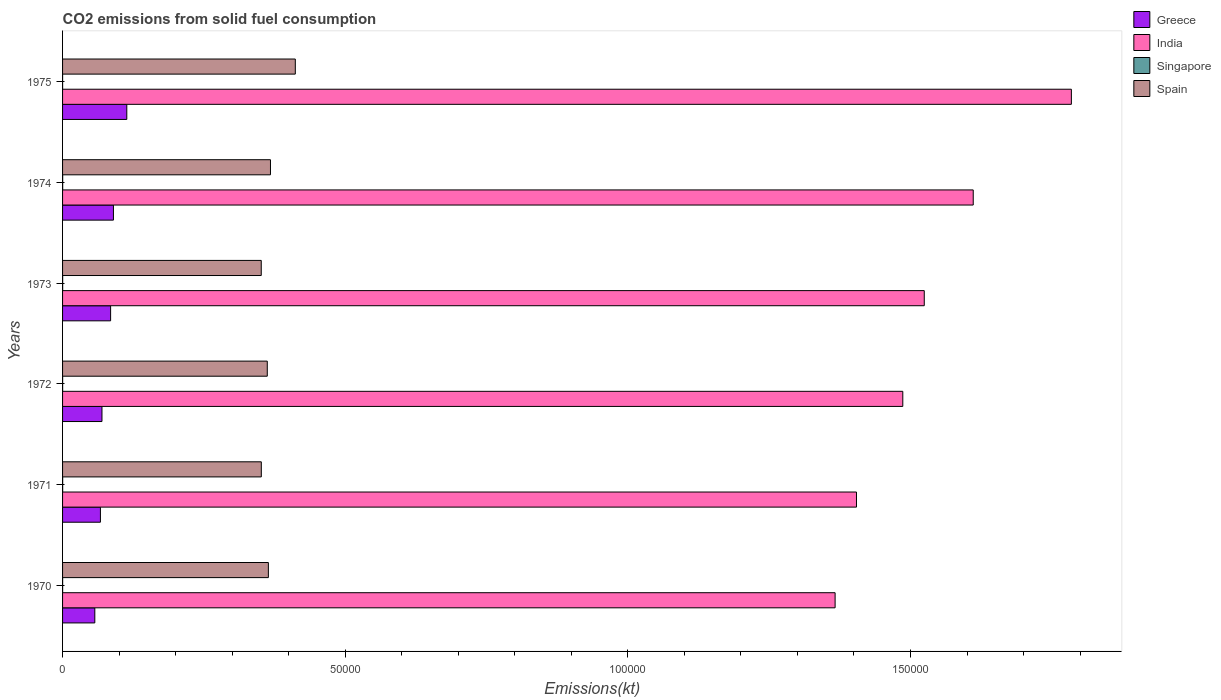How many different coloured bars are there?
Provide a succinct answer. 4. Are the number of bars on each tick of the Y-axis equal?
Provide a short and direct response. Yes. How many bars are there on the 3rd tick from the top?
Ensure brevity in your answer.  4. What is the label of the 3rd group of bars from the top?
Give a very brief answer. 1973. What is the amount of CO2 emitted in Greece in 1973?
Ensure brevity in your answer.  8500.11. Across all years, what is the maximum amount of CO2 emitted in Singapore?
Your response must be concise. 18.34. Across all years, what is the minimum amount of CO2 emitted in India?
Offer a very short reply. 1.37e+05. In which year was the amount of CO2 emitted in Spain maximum?
Offer a very short reply. 1975. In which year was the amount of CO2 emitted in Singapore minimum?
Provide a short and direct response. 1975. What is the total amount of CO2 emitted in Greece in the graph?
Offer a very short reply. 4.82e+04. What is the difference between the amount of CO2 emitted in Spain in 1970 and that in 1975?
Make the answer very short. -4763.43. What is the difference between the amount of CO2 emitted in India in 1973 and the amount of CO2 emitted in Greece in 1972?
Offer a very short reply. 1.45e+05. What is the average amount of CO2 emitted in Spain per year?
Ensure brevity in your answer.  3.68e+04. In the year 1973, what is the difference between the amount of CO2 emitted in Singapore and amount of CO2 emitted in India?
Your answer should be very brief. -1.52e+05. Is the difference between the amount of CO2 emitted in Singapore in 1971 and 1972 greater than the difference between the amount of CO2 emitted in India in 1971 and 1972?
Make the answer very short. Yes. What is the difference between the highest and the second highest amount of CO2 emitted in Singapore?
Keep it short and to the point. 3.67. What is the difference between the highest and the lowest amount of CO2 emitted in Singapore?
Offer a terse response. 14.67. What does the 4th bar from the top in 1973 represents?
Give a very brief answer. Greece. What does the 1st bar from the bottom in 1973 represents?
Your answer should be very brief. Greece. Is it the case that in every year, the sum of the amount of CO2 emitted in Singapore and amount of CO2 emitted in Spain is greater than the amount of CO2 emitted in India?
Offer a very short reply. No. How many years are there in the graph?
Offer a very short reply. 6. Where does the legend appear in the graph?
Ensure brevity in your answer.  Top right. What is the title of the graph?
Your answer should be compact. CO2 emissions from solid fuel consumption. Does "Turkmenistan" appear as one of the legend labels in the graph?
Make the answer very short. No. What is the label or title of the X-axis?
Offer a very short reply. Emissions(kt). What is the Emissions(kt) in Greece in 1970?
Offer a terse response. 5705.85. What is the Emissions(kt) of India in 1970?
Your answer should be compact. 1.37e+05. What is the Emissions(kt) of Singapore in 1970?
Offer a terse response. 11. What is the Emissions(kt) in Spain in 1970?
Provide a short and direct response. 3.64e+04. What is the Emissions(kt) of Greece in 1971?
Provide a short and direct response. 6695.94. What is the Emissions(kt) in India in 1971?
Your answer should be compact. 1.40e+05. What is the Emissions(kt) of Singapore in 1971?
Make the answer very short. 14.67. What is the Emissions(kt) of Spain in 1971?
Ensure brevity in your answer.  3.52e+04. What is the Emissions(kt) in Greece in 1972?
Your answer should be very brief. 6970.97. What is the Emissions(kt) of India in 1972?
Keep it short and to the point. 1.49e+05. What is the Emissions(kt) of Singapore in 1972?
Give a very brief answer. 11. What is the Emissions(kt) of Spain in 1972?
Offer a terse response. 3.62e+04. What is the Emissions(kt) in Greece in 1973?
Give a very brief answer. 8500.11. What is the Emissions(kt) in India in 1973?
Offer a terse response. 1.52e+05. What is the Emissions(kt) in Singapore in 1973?
Your answer should be very brief. 14.67. What is the Emissions(kt) in Spain in 1973?
Your answer should be compact. 3.51e+04. What is the Emissions(kt) of Greece in 1974?
Make the answer very short. 8998.82. What is the Emissions(kt) of India in 1974?
Your answer should be very brief. 1.61e+05. What is the Emissions(kt) in Singapore in 1974?
Provide a succinct answer. 18.34. What is the Emissions(kt) in Spain in 1974?
Your answer should be compact. 3.68e+04. What is the Emissions(kt) in Greece in 1975?
Your response must be concise. 1.14e+04. What is the Emissions(kt) in India in 1975?
Offer a very short reply. 1.78e+05. What is the Emissions(kt) of Singapore in 1975?
Your answer should be very brief. 3.67. What is the Emissions(kt) in Spain in 1975?
Ensure brevity in your answer.  4.12e+04. Across all years, what is the maximum Emissions(kt) of Greece?
Keep it short and to the point. 1.14e+04. Across all years, what is the maximum Emissions(kt) in India?
Make the answer very short. 1.78e+05. Across all years, what is the maximum Emissions(kt) of Singapore?
Make the answer very short. 18.34. Across all years, what is the maximum Emissions(kt) in Spain?
Offer a very short reply. 4.12e+04. Across all years, what is the minimum Emissions(kt) of Greece?
Keep it short and to the point. 5705.85. Across all years, what is the minimum Emissions(kt) of India?
Your response must be concise. 1.37e+05. Across all years, what is the minimum Emissions(kt) in Singapore?
Your answer should be compact. 3.67. Across all years, what is the minimum Emissions(kt) of Spain?
Offer a terse response. 3.51e+04. What is the total Emissions(kt) of Greece in the graph?
Keep it short and to the point. 4.82e+04. What is the total Emissions(kt) in India in the graph?
Your answer should be compact. 9.18e+05. What is the total Emissions(kt) of Singapore in the graph?
Your answer should be compact. 73.34. What is the total Emissions(kt) in Spain in the graph?
Keep it short and to the point. 2.21e+05. What is the difference between the Emissions(kt) of Greece in 1970 and that in 1971?
Keep it short and to the point. -990.09. What is the difference between the Emissions(kt) of India in 1970 and that in 1971?
Offer a very short reply. -3780.68. What is the difference between the Emissions(kt) of Singapore in 1970 and that in 1971?
Offer a very short reply. -3.67. What is the difference between the Emissions(kt) of Spain in 1970 and that in 1971?
Your answer should be compact. 1250.45. What is the difference between the Emissions(kt) of Greece in 1970 and that in 1972?
Provide a short and direct response. -1265.12. What is the difference between the Emissions(kt) of India in 1970 and that in 1972?
Your answer should be compact. -1.20e+04. What is the difference between the Emissions(kt) of Singapore in 1970 and that in 1972?
Offer a very short reply. 0. What is the difference between the Emissions(kt) in Spain in 1970 and that in 1972?
Offer a terse response. 194.35. What is the difference between the Emissions(kt) in Greece in 1970 and that in 1973?
Ensure brevity in your answer.  -2794.25. What is the difference between the Emissions(kt) in India in 1970 and that in 1973?
Your answer should be compact. -1.58e+04. What is the difference between the Emissions(kt) in Singapore in 1970 and that in 1973?
Give a very brief answer. -3.67. What is the difference between the Emissions(kt) of Spain in 1970 and that in 1973?
Offer a very short reply. 1261.45. What is the difference between the Emissions(kt) in Greece in 1970 and that in 1974?
Provide a succinct answer. -3292.97. What is the difference between the Emissions(kt) in India in 1970 and that in 1974?
Offer a very short reply. -2.44e+04. What is the difference between the Emissions(kt) of Singapore in 1970 and that in 1974?
Offer a very short reply. -7.33. What is the difference between the Emissions(kt) of Spain in 1970 and that in 1974?
Your response must be concise. -370.37. What is the difference between the Emissions(kt) in Greece in 1970 and that in 1975?
Provide a succinct answer. -5658.18. What is the difference between the Emissions(kt) of India in 1970 and that in 1975?
Your response must be concise. -4.18e+04. What is the difference between the Emissions(kt) of Singapore in 1970 and that in 1975?
Ensure brevity in your answer.  7.33. What is the difference between the Emissions(kt) of Spain in 1970 and that in 1975?
Make the answer very short. -4763.43. What is the difference between the Emissions(kt) of Greece in 1971 and that in 1972?
Provide a succinct answer. -275.02. What is the difference between the Emissions(kt) in India in 1971 and that in 1972?
Offer a terse response. -8192.08. What is the difference between the Emissions(kt) of Singapore in 1971 and that in 1972?
Provide a succinct answer. 3.67. What is the difference between the Emissions(kt) in Spain in 1971 and that in 1972?
Offer a very short reply. -1056.1. What is the difference between the Emissions(kt) of Greece in 1971 and that in 1973?
Your response must be concise. -1804.16. What is the difference between the Emissions(kt) in India in 1971 and that in 1973?
Your answer should be very brief. -1.20e+04. What is the difference between the Emissions(kt) in Spain in 1971 and that in 1973?
Your answer should be very brief. 11. What is the difference between the Emissions(kt) of Greece in 1971 and that in 1974?
Keep it short and to the point. -2302.88. What is the difference between the Emissions(kt) in India in 1971 and that in 1974?
Offer a very short reply. -2.07e+04. What is the difference between the Emissions(kt) of Singapore in 1971 and that in 1974?
Keep it short and to the point. -3.67. What is the difference between the Emissions(kt) of Spain in 1971 and that in 1974?
Your response must be concise. -1620.81. What is the difference between the Emissions(kt) of Greece in 1971 and that in 1975?
Offer a terse response. -4668.09. What is the difference between the Emissions(kt) in India in 1971 and that in 1975?
Your answer should be compact. -3.80e+04. What is the difference between the Emissions(kt) in Singapore in 1971 and that in 1975?
Offer a terse response. 11. What is the difference between the Emissions(kt) of Spain in 1971 and that in 1975?
Ensure brevity in your answer.  -6013.88. What is the difference between the Emissions(kt) in Greece in 1972 and that in 1973?
Provide a succinct answer. -1529.14. What is the difference between the Emissions(kt) in India in 1972 and that in 1973?
Your response must be concise. -3799.01. What is the difference between the Emissions(kt) of Singapore in 1972 and that in 1973?
Offer a terse response. -3.67. What is the difference between the Emissions(kt) of Spain in 1972 and that in 1973?
Give a very brief answer. 1067.1. What is the difference between the Emissions(kt) in Greece in 1972 and that in 1974?
Offer a very short reply. -2027.85. What is the difference between the Emissions(kt) in India in 1972 and that in 1974?
Provide a short and direct response. -1.25e+04. What is the difference between the Emissions(kt) of Singapore in 1972 and that in 1974?
Your answer should be very brief. -7.33. What is the difference between the Emissions(kt) in Spain in 1972 and that in 1974?
Provide a short and direct response. -564.72. What is the difference between the Emissions(kt) in Greece in 1972 and that in 1975?
Offer a terse response. -4393.07. What is the difference between the Emissions(kt) in India in 1972 and that in 1975?
Offer a very short reply. -2.98e+04. What is the difference between the Emissions(kt) of Singapore in 1972 and that in 1975?
Offer a very short reply. 7.33. What is the difference between the Emissions(kt) in Spain in 1972 and that in 1975?
Ensure brevity in your answer.  -4957.78. What is the difference between the Emissions(kt) in Greece in 1973 and that in 1974?
Ensure brevity in your answer.  -498.71. What is the difference between the Emissions(kt) in India in 1973 and that in 1974?
Provide a succinct answer. -8661.45. What is the difference between the Emissions(kt) in Singapore in 1973 and that in 1974?
Provide a succinct answer. -3.67. What is the difference between the Emissions(kt) in Spain in 1973 and that in 1974?
Make the answer very short. -1631.82. What is the difference between the Emissions(kt) of Greece in 1973 and that in 1975?
Ensure brevity in your answer.  -2863.93. What is the difference between the Emissions(kt) of India in 1973 and that in 1975?
Ensure brevity in your answer.  -2.60e+04. What is the difference between the Emissions(kt) in Singapore in 1973 and that in 1975?
Offer a terse response. 11. What is the difference between the Emissions(kt) in Spain in 1973 and that in 1975?
Offer a terse response. -6024.88. What is the difference between the Emissions(kt) of Greece in 1974 and that in 1975?
Provide a succinct answer. -2365.22. What is the difference between the Emissions(kt) of India in 1974 and that in 1975?
Your answer should be very brief. -1.74e+04. What is the difference between the Emissions(kt) of Singapore in 1974 and that in 1975?
Your answer should be compact. 14.67. What is the difference between the Emissions(kt) in Spain in 1974 and that in 1975?
Provide a short and direct response. -4393.07. What is the difference between the Emissions(kt) of Greece in 1970 and the Emissions(kt) of India in 1971?
Provide a short and direct response. -1.35e+05. What is the difference between the Emissions(kt) of Greece in 1970 and the Emissions(kt) of Singapore in 1971?
Keep it short and to the point. 5691.18. What is the difference between the Emissions(kt) in Greece in 1970 and the Emissions(kt) in Spain in 1971?
Offer a very short reply. -2.95e+04. What is the difference between the Emissions(kt) in India in 1970 and the Emissions(kt) in Singapore in 1971?
Provide a succinct answer. 1.37e+05. What is the difference between the Emissions(kt) in India in 1970 and the Emissions(kt) in Spain in 1971?
Your answer should be compact. 1.02e+05. What is the difference between the Emissions(kt) in Singapore in 1970 and the Emissions(kt) in Spain in 1971?
Provide a succinct answer. -3.51e+04. What is the difference between the Emissions(kt) in Greece in 1970 and the Emissions(kt) in India in 1972?
Provide a succinct answer. -1.43e+05. What is the difference between the Emissions(kt) of Greece in 1970 and the Emissions(kt) of Singapore in 1972?
Ensure brevity in your answer.  5694.85. What is the difference between the Emissions(kt) of Greece in 1970 and the Emissions(kt) of Spain in 1972?
Offer a very short reply. -3.05e+04. What is the difference between the Emissions(kt) in India in 1970 and the Emissions(kt) in Singapore in 1972?
Your answer should be compact. 1.37e+05. What is the difference between the Emissions(kt) of India in 1970 and the Emissions(kt) of Spain in 1972?
Ensure brevity in your answer.  1.00e+05. What is the difference between the Emissions(kt) in Singapore in 1970 and the Emissions(kt) in Spain in 1972?
Your response must be concise. -3.62e+04. What is the difference between the Emissions(kt) of Greece in 1970 and the Emissions(kt) of India in 1973?
Ensure brevity in your answer.  -1.47e+05. What is the difference between the Emissions(kt) in Greece in 1970 and the Emissions(kt) in Singapore in 1973?
Offer a very short reply. 5691.18. What is the difference between the Emissions(kt) of Greece in 1970 and the Emissions(kt) of Spain in 1973?
Offer a very short reply. -2.94e+04. What is the difference between the Emissions(kt) in India in 1970 and the Emissions(kt) in Singapore in 1973?
Keep it short and to the point. 1.37e+05. What is the difference between the Emissions(kt) of India in 1970 and the Emissions(kt) of Spain in 1973?
Give a very brief answer. 1.02e+05. What is the difference between the Emissions(kt) of Singapore in 1970 and the Emissions(kt) of Spain in 1973?
Ensure brevity in your answer.  -3.51e+04. What is the difference between the Emissions(kt) in Greece in 1970 and the Emissions(kt) in India in 1974?
Provide a succinct answer. -1.55e+05. What is the difference between the Emissions(kt) of Greece in 1970 and the Emissions(kt) of Singapore in 1974?
Your answer should be very brief. 5687.52. What is the difference between the Emissions(kt) of Greece in 1970 and the Emissions(kt) of Spain in 1974?
Your answer should be compact. -3.11e+04. What is the difference between the Emissions(kt) in India in 1970 and the Emissions(kt) in Singapore in 1974?
Keep it short and to the point. 1.37e+05. What is the difference between the Emissions(kt) of India in 1970 and the Emissions(kt) of Spain in 1974?
Your answer should be very brief. 9.99e+04. What is the difference between the Emissions(kt) in Singapore in 1970 and the Emissions(kt) in Spain in 1974?
Ensure brevity in your answer.  -3.68e+04. What is the difference between the Emissions(kt) in Greece in 1970 and the Emissions(kt) in India in 1975?
Make the answer very short. -1.73e+05. What is the difference between the Emissions(kt) in Greece in 1970 and the Emissions(kt) in Singapore in 1975?
Ensure brevity in your answer.  5702.19. What is the difference between the Emissions(kt) of Greece in 1970 and the Emissions(kt) of Spain in 1975?
Give a very brief answer. -3.55e+04. What is the difference between the Emissions(kt) of India in 1970 and the Emissions(kt) of Singapore in 1975?
Make the answer very short. 1.37e+05. What is the difference between the Emissions(kt) of India in 1970 and the Emissions(kt) of Spain in 1975?
Keep it short and to the point. 9.55e+04. What is the difference between the Emissions(kt) in Singapore in 1970 and the Emissions(kt) in Spain in 1975?
Your response must be concise. -4.12e+04. What is the difference between the Emissions(kt) of Greece in 1971 and the Emissions(kt) of India in 1972?
Ensure brevity in your answer.  -1.42e+05. What is the difference between the Emissions(kt) of Greece in 1971 and the Emissions(kt) of Singapore in 1972?
Keep it short and to the point. 6684.94. What is the difference between the Emissions(kt) in Greece in 1971 and the Emissions(kt) in Spain in 1972?
Provide a succinct answer. -2.95e+04. What is the difference between the Emissions(kt) in India in 1971 and the Emissions(kt) in Singapore in 1972?
Keep it short and to the point. 1.40e+05. What is the difference between the Emissions(kt) of India in 1971 and the Emissions(kt) of Spain in 1972?
Give a very brief answer. 1.04e+05. What is the difference between the Emissions(kt) in Singapore in 1971 and the Emissions(kt) in Spain in 1972?
Keep it short and to the point. -3.62e+04. What is the difference between the Emissions(kt) of Greece in 1971 and the Emissions(kt) of India in 1973?
Ensure brevity in your answer.  -1.46e+05. What is the difference between the Emissions(kt) in Greece in 1971 and the Emissions(kt) in Singapore in 1973?
Offer a very short reply. 6681.27. What is the difference between the Emissions(kt) of Greece in 1971 and the Emissions(kt) of Spain in 1973?
Keep it short and to the point. -2.85e+04. What is the difference between the Emissions(kt) of India in 1971 and the Emissions(kt) of Singapore in 1973?
Ensure brevity in your answer.  1.40e+05. What is the difference between the Emissions(kt) in India in 1971 and the Emissions(kt) in Spain in 1973?
Keep it short and to the point. 1.05e+05. What is the difference between the Emissions(kt) of Singapore in 1971 and the Emissions(kt) of Spain in 1973?
Your answer should be compact. -3.51e+04. What is the difference between the Emissions(kt) of Greece in 1971 and the Emissions(kt) of India in 1974?
Offer a very short reply. -1.54e+05. What is the difference between the Emissions(kt) in Greece in 1971 and the Emissions(kt) in Singapore in 1974?
Ensure brevity in your answer.  6677.61. What is the difference between the Emissions(kt) in Greece in 1971 and the Emissions(kt) in Spain in 1974?
Keep it short and to the point. -3.01e+04. What is the difference between the Emissions(kt) of India in 1971 and the Emissions(kt) of Singapore in 1974?
Provide a succinct answer. 1.40e+05. What is the difference between the Emissions(kt) in India in 1971 and the Emissions(kt) in Spain in 1974?
Give a very brief answer. 1.04e+05. What is the difference between the Emissions(kt) of Singapore in 1971 and the Emissions(kt) of Spain in 1974?
Provide a short and direct response. -3.68e+04. What is the difference between the Emissions(kt) in Greece in 1971 and the Emissions(kt) in India in 1975?
Keep it short and to the point. -1.72e+05. What is the difference between the Emissions(kt) of Greece in 1971 and the Emissions(kt) of Singapore in 1975?
Provide a short and direct response. 6692.27. What is the difference between the Emissions(kt) of Greece in 1971 and the Emissions(kt) of Spain in 1975?
Offer a terse response. -3.45e+04. What is the difference between the Emissions(kt) in India in 1971 and the Emissions(kt) in Singapore in 1975?
Make the answer very short. 1.40e+05. What is the difference between the Emissions(kt) in India in 1971 and the Emissions(kt) in Spain in 1975?
Offer a terse response. 9.93e+04. What is the difference between the Emissions(kt) in Singapore in 1971 and the Emissions(kt) in Spain in 1975?
Offer a very short reply. -4.12e+04. What is the difference between the Emissions(kt) of Greece in 1972 and the Emissions(kt) of India in 1973?
Your answer should be very brief. -1.45e+05. What is the difference between the Emissions(kt) in Greece in 1972 and the Emissions(kt) in Singapore in 1973?
Give a very brief answer. 6956.3. What is the difference between the Emissions(kt) in Greece in 1972 and the Emissions(kt) in Spain in 1973?
Ensure brevity in your answer.  -2.82e+04. What is the difference between the Emissions(kt) in India in 1972 and the Emissions(kt) in Singapore in 1973?
Ensure brevity in your answer.  1.49e+05. What is the difference between the Emissions(kt) in India in 1972 and the Emissions(kt) in Spain in 1973?
Ensure brevity in your answer.  1.13e+05. What is the difference between the Emissions(kt) in Singapore in 1972 and the Emissions(kt) in Spain in 1973?
Your response must be concise. -3.51e+04. What is the difference between the Emissions(kt) in Greece in 1972 and the Emissions(kt) in India in 1974?
Provide a short and direct response. -1.54e+05. What is the difference between the Emissions(kt) in Greece in 1972 and the Emissions(kt) in Singapore in 1974?
Offer a terse response. 6952.63. What is the difference between the Emissions(kt) of Greece in 1972 and the Emissions(kt) of Spain in 1974?
Offer a very short reply. -2.98e+04. What is the difference between the Emissions(kt) in India in 1972 and the Emissions(kt) in Singapore in 1974?
Offer a terse response. 1.49e+05. What is the difference between the Emissions(kt) in India in 1972 and the Emissions(kt) in Spain in 1974?
Your answer should be very brief. 1.12e+05. What is the difference between the Emissions(kt) in Singapore in 1972 and the Emissions(kt) in Spain in 1974?
Ensure brevity in your answer.  -3.68e+04. What is the difference between the Emissions(kt) in Greece in 1972 and the Emissions(kt) in India in 1975?
Provide a succinct answer. -1.71e+05. What is the difference between the Emissions(kt) in Greece in 1972 and the Emissions(kt) in Singapore in 1975?
Give a very brief answer. 6967.3. What is the difference between the Emissions(kt) in Greece in 1972 and the Emissions(kt) in Spain in 1975?
Give a very brief answer. -3.42e+04. What is the difference between the Emissions(kt) in India in 1972 and the Emissions(kt) in Singapore in 1975?
Provide a succinct answer. 1.49e+05. What is the difference between the Emissions(kt) in India in 1972 and the Emissions(kt) in Spain in 1975?
Your answer should be very brief. 1.07e+05. What is the difference between the Emissions(kt) of Singapore in 1972 and the Emissions(kt) of Spain in 1975?
Make the answer very short. -4.12e+04. What is the difference between the Emissions(kt) of Greece in 1973 and the Emissions(kt) of India in 1974?
Your answer should be compact. -1.53e+05. What is the difference between the Emissions(kt) in Greece in 1973 and the Emissions(kt) in Singapore in 1974?
Offer a terse response. 8481.77. What is the difference between the Emissions(kt) in Greece in 1973 and the Emissions(kt) in Spain in 1974?
Offer a terse response. -2.83e+04. What is the difference between the Emissions(kt) of India in 1973 and the Emissions(kt) of Singapore in 1974?
Provide a short and direct response. 1.52e+05. What is the difference between the Emissions(kt) in India in 1973 and the Emissions(kt) in Spain in 1974?
Make the answer very short. 1.16e+05. What is the difference between the Emissions(kt) in Singapore in 1973 and the Emissions(kt) in Spain in 1974?
Offer a terse response. -3.68e+04. What is the difference between the Emissions(kt) of Greece in 1973 and the Emissions(kt) of India in 1975?
Make the answer very short. -1.70e+05. What is the difference between the Emissions(kt) of Greece in 1973 and the Emissions(kt) of Singapore in 1975?
Your response must be concise. 8496.44. What is the difference between the Emissions(kt) in Greece in 1973 and the Emissions(kt) in Spain in 1975?
Ensure brevity in your answer.  -3.27e+04. What is the difference between the Emissions(kt) of India in 1973 and the Emissions(kt) of Singapore in 1975?
Provide a succinct answer. 1.52e+05. What is the difference between the Emissions(kt) in India in 1973 and the Emissions(kt) in Spain in 1975?
Your answer should be very brief. 1.11e+05. What is the difference between the Emissions(kt) in Singapore in 1973 and the Emissions(kt) in Spain in 1975?
Your answer should be very brief. -4.12e+04. What is the difference between the Emissions(kt) of Greece in 1974 and the Emissions(kt) of India in 1975?
Make the answer very short. -1.69e+05. What is the difference between the Emissions(kt) in Greece in 1974 and the Emissions(kt) in Singapore in 1975?
Keep it short and to the point. 8995.15. What is the difference between the Emissions(kt) in Greece in 1974 and the Emissions(kt) in Spain in 1975?
Provide a succinct answer. -3.22e+04. What is the difference between the Emissions(kt) of India in 1974 and the Emissions(kt) of Singapore in 1975?
Keep it short and to the point. 1.61e+05. What is the difference between the Emissions(kt) in India in 1974 and the Emissions(kt) in Spain in 1975?
Your response must be concise. 1.20e+05. What is the difference between the Emissions(kt) of Singapore in 1974 and the Emissions(kt) of Spain in 1975?
Your answer should be compact. -4.12e+04. What is the average Emissions(kt) of Greece per year?
Keep it short and to the point. 8039.29. What is the average Emissions(kt) of India per year?
Provide a short and direct response. 1.53e+05. What is the average Emissions(kt) in Singapore per year?
Offer a terse response. 12.22. What is the average Emissions(kt) of Spain per year?
Offer a terse response. 3.68e+04. In the year 1970, what is the difference between the Emissions(kt) of Greece and Emissions(kt) of India?
Provide a succinct answer. -1.31e+05. In the year 1970, what is the difference between the Emissions(kt) in Greece and Emissions(kt) in Singapore?
Provide a short and direct response. 5694.85. In the year 1970, what is the difference between the Emissions(kt) in Greece and Emissions(kt) in Spain?
Your answer should be compact. -3.07e+04. In the year 1970, what is the difference between the Emissions(kt) in India and Emissions(kt) in Singapore?
Offer a very short reply. 1.37e+05. In the year 1970, what is the difference between the Emissions(kt) of India and Emissions(kt) of Spain?
Give a very brief answer. 1.00e+05. In the year 1970, what is the difference between the Emissions(kt) in Singapore and Emissions(kt) in Spain?
Provide a short and direct response. -3.64e+04. In the year 1971, what is the difference between the Emissions(kt) in Greece and Emissions(kt) in India?
Your answer should be compact. -1.34e+05. In the year 1971, what is the difference between the Emissions(kt) of Greece and Emissions(kt) of Singapore?
Your answer should be very brief. 6681.27. In the year 1971, what is the difference between the Emissions(kt) in Greece and Emissions(kt) in Spain?
Your answer should be compact. -2.85e+04. In the year 1971, what is the difference between the Emissions(kt) of India and Emissions(kt) of Singapore?
Make the answer very short. 1.40e+05. In the year 1971, what is the difference between the Emissions(kt) in India and Emissions(kt) in Spain?
Keep it short and to the point. 1.05e+05. In the year 1971, what is the difference between the Emissions(kt) of Singapore and Emissions(kt) of Spain?
Offer a very short reply. -3.51e+04. In the year 1972, what is the difference between the Emissions(kt) in Greece and Emissions(kt) in India?
Offer a terse response. -1.42e+05. In the year 1972, what is the difference between the Emissions(kt) in Greece and Emissions(kt) in Singapore?
Make the answer very short. 6959.97. In the year 1972, what is the difference between the Emissions(kt) in Greece and Emissions(kt) in Spain?
Keep it short and to the point. -2.92e+04. In the year 1972, what is the difference between the Emissions(kt) in India and Emissions(kt) in Singapore?
Give a very brief answer. 1.49e+05. In the year 1972, what is the difference between the Emissions(kt) in India and Emissions(kt) in Spain?
Offer a very short reply. 1.12e+05. In the year 1972, what is the difference between the Emissions(kt) in Singapore and Emissions(kt) in Spain?
Offer a very short reply. -3.62e+04. In the year 1973, what is the difference between the Emissions(kt) of Greece and Emissions(kt) of India?
Ensure brevity in your answer.  -1.44e+05. In the year 1973, what is the difference between the Emissions(kt) in Greece and Emissions(kt) in Singapore?
Your response must be concise. 8485.44. In the year 1973, what is the difference between the Emissions(kt) of Greece and Emissions(kt) of Spain?
Provide a short and direct response. -2.66e+04. In the year 1973, what is the difference between the Emissions(kt) of India and Emissions(kt) of Singapore?
Offer a very short reply. 1.52e+05. In the year 1973, what is the difference between the Emissions(kt) in India and Emissions(kt) in Spain?
Your answer should be very brief. 1.17e+05. In the year 1973, what is the difference between the Emissions(kt) of Singapore and Emissions(kt) of Spain?
Give a very brief answer. -3.51e+04. In the year 1974, what is the difference between the Emissions(kt) in Greece and Emissions(kt) in India?
Offer a terse response. -1.52e+05. In the year 1974, what is the difference between the Emissions(kt) in Greece and Emissions(kt) in Singapore?
Provide a succinct answer. 8980.48. In the year 1974, what is the difference between the Emissions(kt) in Greece and Emissions(kt) in Spain?
Your answer should be compact. -2.78e+04. In the year 1974, what is the difference between the Emissions(kt) in India and Emissions(kt) in Singapore?
Offer a very short reply. 1.61e+05. In the year 1974, what is the difference between the Emissions(kt) in India and Emissions(kt) in Spain?
Your response must be concise. 1.24e+05. In the year 1974, what is the difference between the Emissions(kt) of Singapore and Emissions(kt) of Spain?
Your answer should be very brief. -3.68e+04. In the year 1975, what is the difference between the Emissions(kt) of Greece and Emissions(kt) of India?
Your answer should be very brief. -1.67e+05. In the year 1975, what is the difference between the Emissions(kt) in Greece and Emissions(kt) in Singapore?
Offer a terse response. 1.14e+04. In the year 1975, what is the difference between the Emissions(kt) of Greece and Emissions(kt) of Spain?
Keep it short and to the point. -2.98e+04. In the year 1975, what is the difference between the Emissions(kt) of India and Emissions(kt) of Singapore?
Give a very brief answer. 1.78e+05. In the year 1975, what is the difference between the Emissions(kt) in India and Emissions(kt) in Spain?
Offer a terse response. 1.37e+05. In the year 1975, what is the difference between the Emissions(kt) in Singapore and Emissions(kt) in Spain?
Your answer should be compact. -4.12e+04. What is the ratio of the Emissions(kt) of Greece in 1970 to that in 1971?
Offer a terse response. 0.85. What is the ratio of the Emissions(kt) in India in 1970 to that in 1971?
Provide a succinct answer. 0.97. What is the ratio of the Emissions(kt) of Spain in 1970 to that in 1971?
Provide a short and direct response. 1.04. What is the ratio of the Emissions(kt) in Greece in 1970 to that in 1972?
Offer a terse response. 0.82. What is the ratio of the Emissions(kt) in India in 1970 to that in 1972?
Ensure brevity in your answer.  0.92. What is the ratio of the Emissions(kt) in Spain in 1970 to that in 1972?
Offer a very short reply. 1.01. What is the ratio of the Emissions(kt) of Greece in 1970 to that in 1973?
Your response must be concise. 0.67. What is the ratio of the Emissions(kt) in India in 1970 to that in 1973?
Keep it short and to the point. 0.9. What is the ratio of the Emissions(kt) in Spain in 1970 to that in 1973?
Give a very brief answer. 1.04. What is the ratio of the Emissions(kt) of Greece in 1970 to that in 1974?
Make the answer very short. 0.63. What is the ratio of the Emissions(kt) of India in 1970 to that in 1974?
Provide a short and direct response. 0.85. What is the ratio of the Emissions(kt) in Spain in 1970 to that in 1974?
Keep it short and to the point. 0.99. What is the ratio of the Emissions(kt) in Greece in 1970 to that in 1975?
Ensure brevity in your answer.  0.5. What is the ratio of the Emissions(kt) in India in 1970 to that in 1975?
Give a very brief answer. 0.77. What is the ratio of the Emissions(kt) in Singapore in 1970 to that in 1975?
Offer a terse response. 3. What is the ratio of the Emissions(kt) in Spain in 1970 to that in 1975?
Offer a terse response. 0.88. What is the ratio of the Emissions(kt) of Greece in 1971 to that in 1972?
Offer a terse response. 0.96. What is the ratio of the Emissions(kt) in India in 1971 to that in 1972?
Your answer should be very brief. 0.94. What is the ratio of the Emissions(kt) in Singapore in 1971 to that in 1972?
Offer a terse response. 1.33. What is the ratio of the Emissions(kt) in Spain in 1971 to that in 1972?
Offer a terse response. 0.97. What is the ratio of the Emissions(kt) of Greece in 1971 to that in 1973?
Give a very brief answer. 0.79. What is the ratio of the Emissions(kt) in India in 1971 to that in 1973?
Provide a succinct answer. 0.92. What is the ratio of the Emissions(kt) of Greece in 1971 to that in 1974?
Make the answer very short. 0.74. What is the ratio of the Emissions(kt) of India in 1971 to that in 1974?
Your answer should be very brief. 0.87. What is the ratio of the Emissions(kt) of Singapore in 1971 to that in 1974?
Give a very brief answer. 0.8. What is the ratio of the Emissions(kt) of Spain in 1971 to that in 1974?
Offer a terse response. 0.96. What is the ratio of the Emissions(kt) in Greece in 1971 to that in 1975?
Ensure brevity in your answer.  0.59. What is the ratio of the Emissions(kt) of India in 1971 to that in 1975?
Make the answer very short. 0.79. What is the ratio of the Emissions(kt) of Spain in 1971 to that in 1975?
Offer a terse response. 0.85. What is the ratio of the Emissions(kt) in Greece in 1972 to that in 1973?
Offer a terse response. 0.82. What is the ratio of the Emissions(kt) in India in 1972 to that in 1973?
Keep it short and to the point. 0.98. What is the ratio of the Emissions(kt) of Spain in 1972 to that in 1973?
Give a very brief answer. 1.03. What is the ratio of the Emissions(kt) of Greece in 1972 to that in 1974?
Your answer should be very brief. 0.77. What is the ratio of the Emissions(kt) in India in 1972 to that in 1974?
Offer a very short reply. 0.92. What is the ratio of the Emissions(kt) of Singapore in 1972 to that in 1974?
Your answer should be very brief. 0.6. What is the ratio of the Emissions(kt) in Spain in 1972 to that in 1974?
Provide a short and direct response. 0.98. What is the ratio of the Emissions(kt) in Greece in 1972 to that in 1975?
Provide a short and direct response. 0.61. What is the ratio of the Emissions(kt) of India in 1972 to that in 1975?
Make the answer very short. 0.83. What is the ratio of the Emissions(kt) of Singapore in 1972 to that in 1975?
Provide a short and direct response. 3. What is the ratio of the Emissions(kt) in Spain in 1972 to that in 1975?
Your response must be concise. 0.88. What is the ratio of the Emissions(kt) in Greece in 1973 to that in 1974?
Make the answer very short. 0.94. What is the ratio of the Emissions(kt) of India in 1973 to that in 1974?
Your answer should be very brief. 0.95. What is the ratio of the Emissions(kt) of Singapore in 1973 to that in 1974?
Make the answer very short. 0.8. What is the ratio of the Emissions(kt) in Spain in 1973 to that in 1974?
Provide a short and direct response. 0.96. What is the ratio of the Emissions(kt) in Greece in 1973 to that in 1975?
Provide a short and direct response. 0.75. What is the ratio of the Emissions(kt) of India in 1973 to that in 1975?
Your answer should be very brief. 0.85. What is the ratio of the Emissions(kt) in Spain in 1973 to that in 1975?
Keep it short and to the point. 0.85. What is the ratio of the Emissions(kt) of Greece in 1974 to that in 1975?
Your answer should be very brief. 0.79. What is the ratio of the Emissions(kt) in India in 1974 to that in 1975?
Your response must be concise. 0.9. What is the ratio of the Emissions(kt) of Singapore in 1974 to that in 1975?
Offer a very short reply. 5. What is the ratio of the Emissions(kt) of Spain in 1974 to that in 1975?
Offer a very short reply. 0.89. What is the difference between the highest and the second highest Emissions(kt) of Greece?
Keep it short and to the point. 2365.22. What is the difference between the highest and the second highest Emissions(kt) of India?
Provide a short and direct response. 1.74e+04. What is the difference between the highest and the second highest Emissions(kt) in Singapore?
Make the answer very short. 3.67. What is the difference between the highest and the second highest Emissions(kt) in Spain?
Your answer should be very brief. 4393.07. What is the difference between the highest and the lowest Emissions(kt) of Greece?
Your answer should be very brief. 5658.18. What is the difference between the highest and the lowest Emissions(kt) in India?
Your answer should be very brief. 4.18e+04. What is the difference between the highest and the lowest Emissions(kt) in Singapore?
Keep it short and to the point. 14.67. What is the difference between the highest and the lowest Emissions(kt) of Spain?
Provide a succinct answer. 6024.88. 